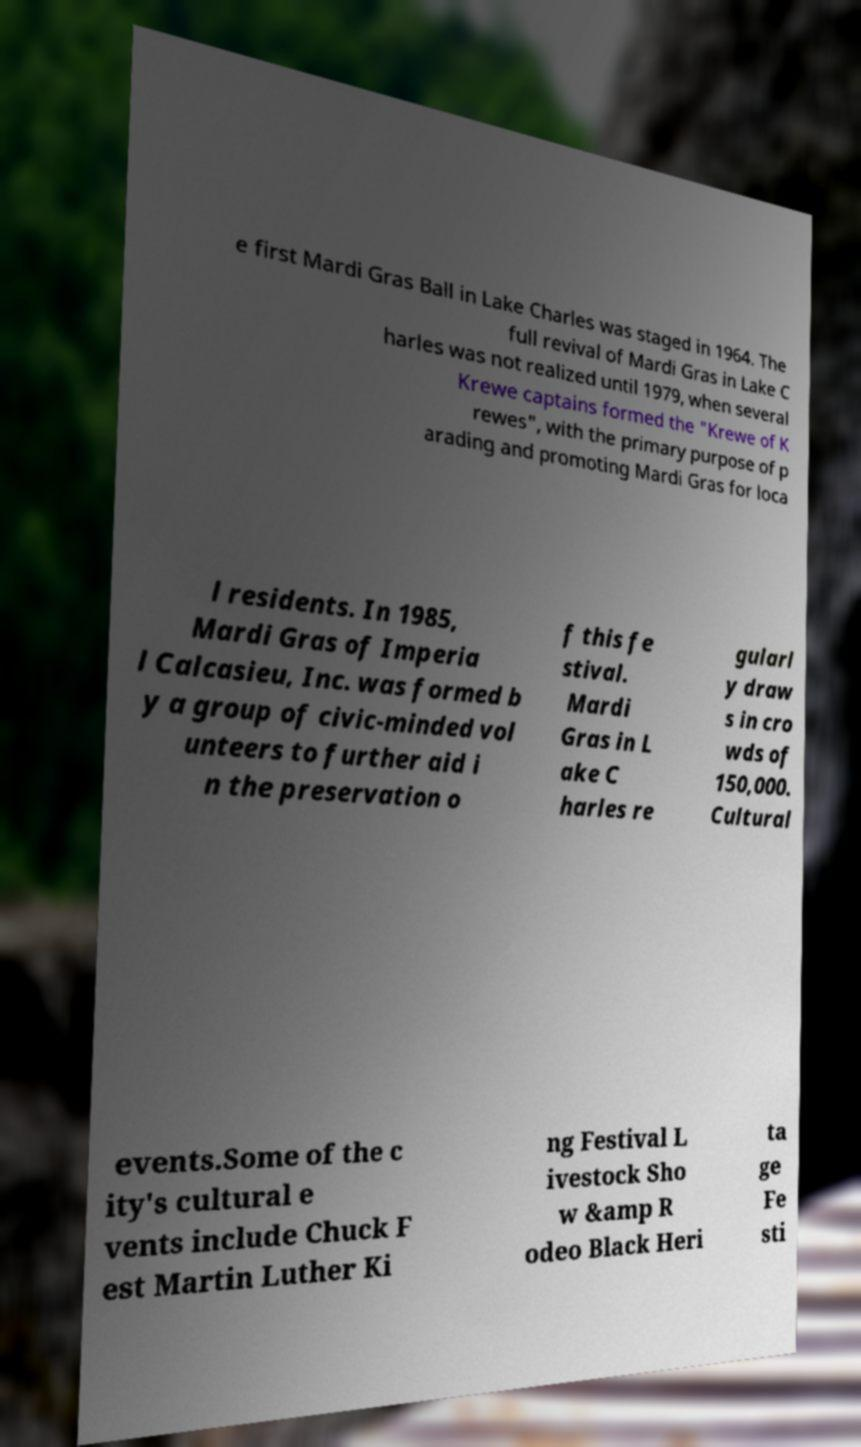What messages or text are displayed in this image? I need them in a readable, typed format. e first Mardi Gras Ball in Lake Charles was staged in 1964. The full revival of Mardi Gras in Lake C harles was not realized until 1979, when several Krewe captains formed the "Krewe of K rewes", with the primary purpose of p arading and promoting Mardi Gras for loca l residents. In 1985, Mardi Gras of Imperia l Calcasieu, Inc. was formed b y a group of civic-minded vol unteers to further aid i n the preservation o f this fe stival. Mardi Gras in L ake C harles re gularl y draw s in cro wds of 150,000. Cultural events.Some of the c ity's cultural e vents include Chuck F est Martin Luther Ki ng Festival L ivestock Sho w &amp R odeo Black Heri ta ge Fe sti 